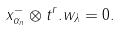Convert formula to latex. <formula><loc_0><loc_0><loc_500><loc_500>x _ { \alpha _ { n } } ^ { - } \otimes t ^ { r } . w _ { \lambda } = 0 .</formula> 